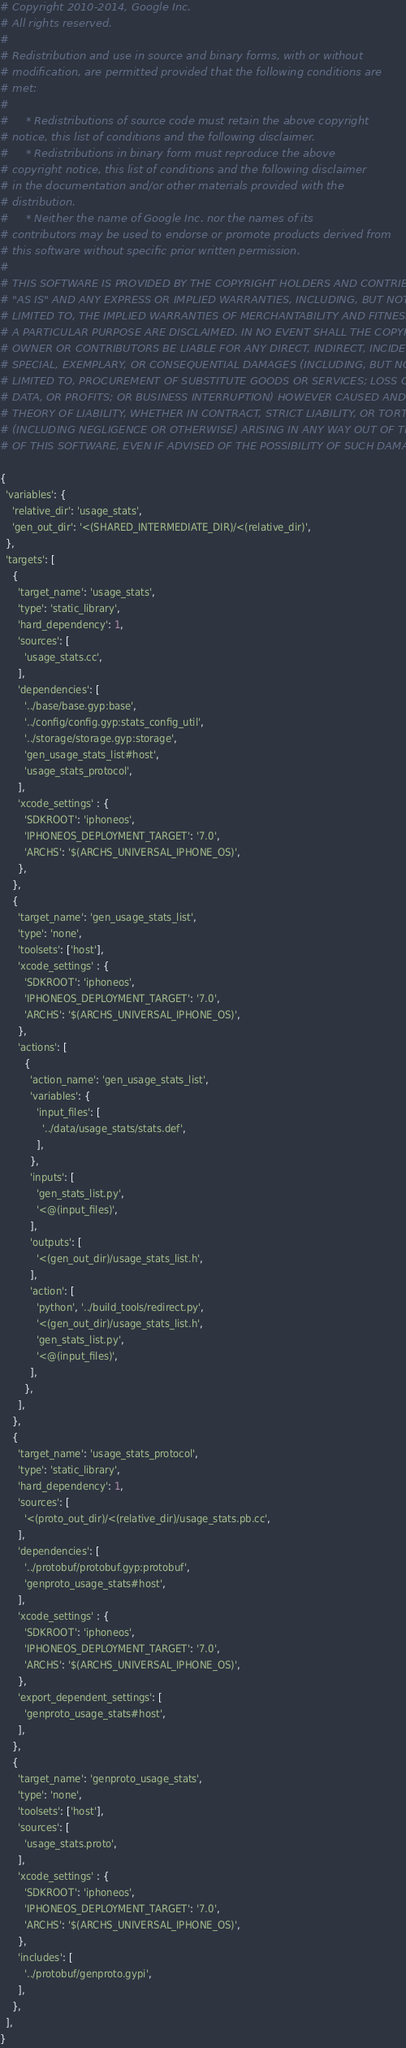Convert code to text. <code><loc_0><loc_0><loc_500><loc_500><_Python_># Copyright 2010-2014, Google Inc.
# All rights reserved.
#
# Redistribution and use in source and binary forms, with or without
# modification, are permitted provided that the following conditions are
# met:
#
#     * Redistributions of source code must retain the above copyright
# notice, this list of conditions and the following disclaimer.
#     * Redistributions in binary form must reproduce the above
# copyright notice, this list of conditions and the following disclaimer
# in the documentation and/or other materials provided with the
# distribution.
#     * Neither the name of Google Inc. nor the names of its
# contributors may be used to endorse or promote products derived from
# this software without specific prior written permission.
#
# THIS SOFTWARE IS PROVIDED BY THE COPYRIGHT HOLDERS AND CONTRIBUTORS
# "AS IS" AND ANY EXPRESS OR IMPLIED WARRANTIES, INCLUDING, BUT NOT
# LIMITED TO, THE IMPLIED WARRANTIES OF MERCHANTABILITY AND FITNESS FOR
# A PARTICULAR PURPOSE ARE DISCLAIMED. IN NO EVENT SHALL THE COPYRIGHT
# OWNER OR CONTRIBUTORS BE LIABLE FOR ANY DIRECT, INDIRECT, INCIDENTAL,
# SPECIAL, EXEMPLARY, OR CONSEQUENTIAL DAMAGES (INCLUDING, BUT NOT
# LIMITED TO, PROCUREMENT OF SUBSTITUTE GOODS OR SERVICES; LOSS OF USE,
# DATA, OR PROFITS; OR BUSINESS INTERRUPTION) HOWEVER CAUSED AND ON ANY
# THEORY OF LIABILITY, WHETHER IN CONTRACT, STRICT LIABILITY, OR TORT
# (INCLUDING NEGLIGENCE OR OTHERWISE) ARISING IN ANY WAY OUT OF THE USE
# OF THIS SOFTWARE, EVEN IF ADVISED OF THE POSSIBILITY OF SUCH DAMAGE.

{
  'variables': {
    'relative_dir': 'usage_stats',
    'gen_out_dir': '<(SHARED_INTERMEDIATE_DIR)/<(relative_dir)',
  },
  'targets': [
    {
      'target_name': 'usage_stats',
      'type': 'static_library',
      'hard_dependency': 1,
      'sources': [
        'usage_stats.cc',
      ],
      'dependencies': [
        '../base/base.gyp:base',
        '../config/config.gyp:stats_config_util',
        '../storage/storage.gyp:storage',
        'gen_usage_stats_list#host',
        'usage_stats_protocol',
      ],
      'xcode_settings' : {
        'SDKROOT': 'iphoneos',
        'IPHONEOS_DEPLOYMENT_TARGET': '7.0',
        'ARCHS': '$(ARCHS_UNIVERSAL_IPHONE_OS)',
      },
    },
    {
      'target_name': 'gen_usage_stats_list',
      'type': 'none',
      'toolsets': ['host'],
      'xcode_settings' : {
        'SDKROOT': 'iphoneos',
        'IPHONEOS_DEPLOYMENT_TARGET': '7.0',
        'ARCHS': '$(ARCHS_UNIVERSAL_IPHONE_OS)',
      },
      'actions': [
        {
          'action_name': 'gen_usage_stats_list',
          'variables': {
            'input_files': [
              '../data/usage_stats/stats.def',
            ],
          },
          'inputs': [
            'gen_stats_list.py',
            '<@(input_files)',
          ],
          'outputs': [
            '<(gen_out_dir)/usage_stats_list.h',
          ],
          'action': [
            'python', '../build_tools/redirect.py',
            '<(gen_out_dir)/usage_stats_list.h',
            'gen_stats_list.py',
            '<@(input_files)',
          ],
        },
      ],
    },
    {
      'target_name': 'usage_stats_protocol',
      'type': 'static_library',
      'hard_dependency': 1,
      'sources': [
        '<(proto_out_dir)/<(relative_dir)/usage_stats.pb.cc',
      ],
      'dependencies': [
        '../protobuf/protobuf.gyp:protobuf',
        'genproto_usage_stats#host',
      ],
      'xcode_settings' : {
        'SDKROOT': 'iphoneos',
        'IPHONEOS_DEPLOYMENT_TARGET': '7.0',
        'ARCHS': '$(ARCHS_UNIVERSAL_IPHONE_OS)',
      },
      'export_dependent_settings': [
        'genproto_usage_stats#host',
      ],
    },
    {
      'target_name': 'genproto_usage_stats',
      'type': 'none',
      'toolsets': ['host'],
      'sources': [
        'usage_stats.proto',
      ],
      'xcode_settings' : {
        'SDKROOT': 'iphoneos',
        'IPHONEOS_DEPLOYMENT_TARGET': '7.0',
        'ARCHS': '$(ARCHS_UNIVERSAL_IPHONE_OS)',
      },
      'includes': [
        '../protobuf/genproto.gypi',
      ],
    },
  ],
}
</code> 